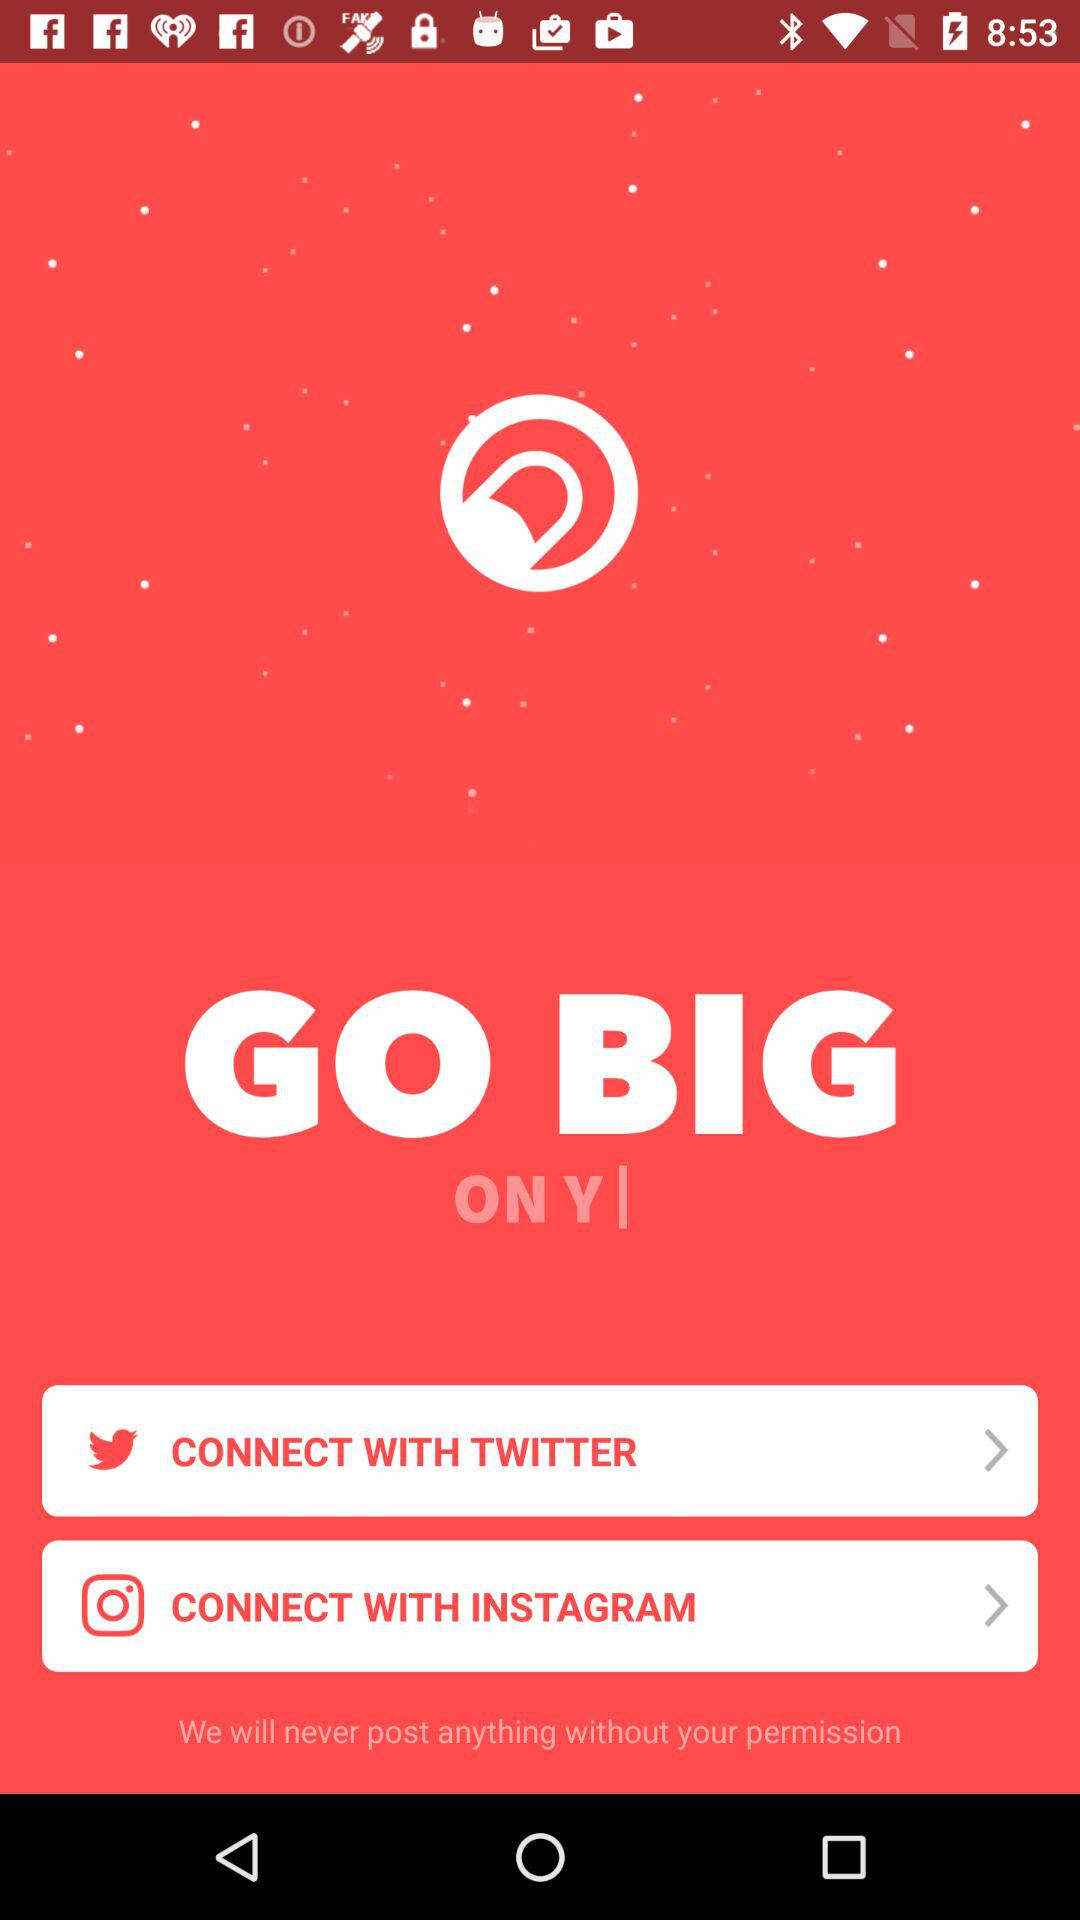What is the app name? The app name is "crowdfire". 